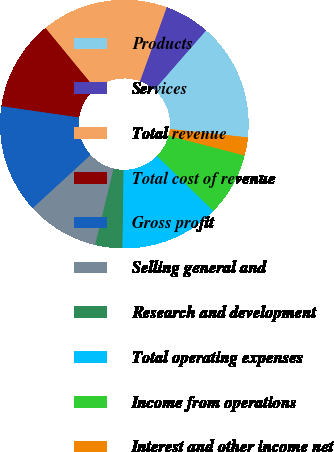<chart> <loc_0><loc_0><loc_500><loc_500><pie_chart><fcel>Products<fcel>Services<fcel>Total revenue<fcel>Total cost of revenue<fcel>Gross profit<fcel>Selling general and<fcel>Research and development<fcel>Total operating expenses<fcel>Income from operations<fcel>Interest and other income net<nl><fcel>15.29%<fcel>5.88%<fcel>16.47%<fcel>11.76%<fcel>14.12%<fcel>9.41%<fcel>3.53%<fcel>12.94%<fcel>8.24%<fcel>2.35%<nl></chart> 